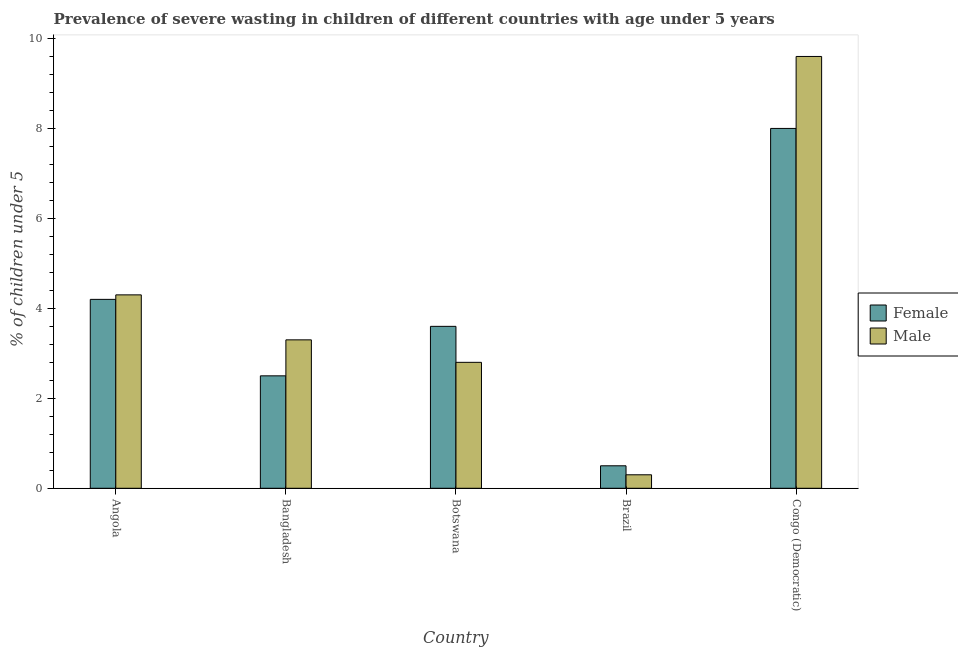How many different coloured bars are there?
Provide a short and direct response. 2. How many groups of bars are there?
Your answer should be compact. 5. Are the number of bars per tick equal to the number of legend labels?
Provide a short and direct response. Yes. How many bars are there on the 1st tick from the right?
Offer a terse response. 2. What is the label of the 4th group of bars from the left?
Offer a very short reply. Brazil. Across all countries, what is the maximum percentage of undernourished male children?
Your response must be concise. 9.6. Across all countries, what is the minimum percentage of undernourished male children?
Your answer should be very brief. 0.3. In which country was the percentage of undernourished male children maximum?
Ensure brevity in your answer.  Congo (Democratic). In which country was the percentage of undernourished female children minimum?
Your answer should be very brief. Brazil. What is the total percentage of undernourished male children in the graph?
Offer a very short reply. 20.3. What is the difference between the percentage of undernourished female children in Botswana and that in Congo (Democratic)?
Your answer should be very brief. -4.4. What is the difference between the percentage of undernourished female children in Brazil and the percentage of undernourished male children in Botswana?
Offer a very short reply. -2.3. What is the average percentage of undernourished male children per country?
Offer a terse response. 4.06. What is the difference between the percentage of undernourished male children and percentage of undernourished female children in Bangladesh?
Your answer should be compact. 0.8. In how many countries, is the percentage of undernourished male children greater than 6.4 %?
Give a very brief answer. 1. What is the ratio of the percentage of undernourished male children in Bangladesh to that in Congo (Democratic)?
Your answer should be very brief. 0.34. Is the percentage of undernourished male children in Bangladesh less than that in Botswana?
Your response must be concise. No. Is the difference between the percentage of undernourished male children in Brazil and Congo (Democratic) greater than the difference between the percentage of undernourished female children in Brazil and Congo (Democratic)?
Offer a terse response. No. What is the difference between the highest and the second highest percentage of undernourished male children?
Make the answer very short. 5.3. What is the difference between the highest and the lowest percentage of undernourished male children?
Your answer should be compact. 9.3. In how many countries, is the percentage of undernourished female children greater than the average percentage of undernourished female children taken over all countries?
Make the answer very short. 2. Is the sum of the percentage of undernourished male children in Angola and Congo (Democratic) greater than the maximum percentage of undernourished female children across all countries?
Give a very brief answer. Yes. What does the 2nd bar from the left in Brazil represents?
Your answer should be very brief. Male. What does the 1st bar from the right in Botswana represents?
Your response must be concise. Male. How many countries are there in the graph?
Provide a short and direct response. 5. What is the difference between two consecutive major ticks on the Y-axis?
Keep it short and to the point. 2. Are the values on the major ticks of Y-axis written in scientific E-notation?
Your answer should be compact. No. How many legend labels are there?
Give a very brief answer. 2. How are the legend labels stacked?
Make the answer very short. Vertical. What is the title of the graph?
Offer a terse response. Prevalence of severe wasting in children of different countries with age under 5 years. Does "Travel services" appear as one of the legend labels in the graph?
Your answer should be very brief. No. What is the label or title of the X-axis?
Offer a very short reply. Country. What is the label or title of the Y-axis?
Ensure brevity in your answer.   % of children under 5. What is the  % of children under 5 of Female in Angola?
Provide a short and direct response. 4.2. What is the  % of children under 5 in Male in Angola?
Keep it short and to the point. 4.3. What is the  % of children under 5 in Female in Bangladesh?
Offer a very short reply. 2.5. What is the  % of children under 5 in Male in Bangladesh?
Your answer should be very brief. 3.3. What is the  % of children under 5 of Female in Botswana?
Your response must be concise. 3.6. What is the  % of children under 5 in Male in Botswana?
Your response must be concise. 2.8. What is the  % of children under 5 of Female in Brazil?
Your answer should be compact. 0.5. What is the  % of children under 5 in Male in Brazil?
Offer a terse response. 0.3. What is the  % of children under 5 of Female in Congo (Democratic)?
Your response must be concise. 8. What is the  % of children under 5 of Male in Congo (Democratic)?
Your response must be concise. 9.6. Across all countries, what is the maximum  % of children under 5 in Female?
Provide a short and direct response. 8. Across all countries, what is the maximum  % of children under 5 of Male?
Make the answer very short. 9.6. Across all countries, what is the minimum  % of children under 5 of Male?
Your answer should be compact. 0.3. What is the total  % of children under 5 in Male in the graph?
Keep it short and to the point. 20.3. What is the difference between the  % of children under 5 in Male in Angola and that in Bangladesh?
Your answer should be very brief. 1. What is the difference between the  % of children under 5 of Male in Angola and that in Brazil?
Provide a succinct answer. 4. What is the difference between the  % of children under 5 in Female in Angola and that in Congo (Democratic)?
Ensure brevity in your answer.  -3.8. What is the difference between the  % of children under 5 of Male in Angola and that in Congo (Democratic)?
Your answer should be very brief. -5.3. What is the difference between the  % of children under 5 in Female in Bangladesh and that in Brazil?
Give a very brief answer. 2. What is the difference between the  % of children under 5 of Male in Bangladesh and that in Brazil?
Offer a terse response. 3. What is the difference between the  % of children under 5 of Female in Bangladesh and that in Congo (Democratic)?
Provide a succinct answer. -5.5. What is the difference between the  % of children under 5 in Male in Bangladesh and that in Congo (Democratic)?
Provide a succinct answer. -6.3. What is the difference between the  % of children under 5 in Female in Botswana and that in Brazil?
Provide a short and direct response. 3.1. What is the difference between the  % of children under 5 of Male in Botswana and that in Brazil?
Provide a short and direct response. 2.5. What is the difference between the  % of children under 5 in Female in Botswana and that in Congo (Democratic)?
Your response must be concise. -4.4. What is the difference between the  % of children under 5 of Male in Botswana and that in Congo (Democratic)?
Keep it short and to the point. -6.8. What is the difference between the  % of children under 5 in Female in Brazil and that in Congo (Democratic)?
Your response must be concise. -7.5. What is the difference between the  % of children under 5 in Male in Brazil and that in Congo (Democratic)?
Your response must be concise. -9.3. What is the difference between the  % of children under 5 of Female in Angola and the  % of children under 5 of Male in Botswana?
Give a very brief answer. 1.4. What is the difference between the  % of children under 5 of Female in Angola and the  % of children under 5 of Male in Brazil?
Provide a short and direct response. 3.9. What is the difference between the  % of children under 5 of Female in Angola and the  % of children under 5 of Male in Congo (Democratic)?
Your answer should be very brief. -5.4. What is the difference between the  % of children under 5 of Female in Bangladesh and the  % of children under 5 of Male in Brazil?
Offer a very short reply. 2.2. What is the difference between the  % of children under 5 in Female in Bangladesh and the  % of children under 5 in Male in Congo (Democratic)?
Provide a succinct answer. -7.1. What is the difference between the  % of children under 5 of Female in Botswana and the  % of children under 5 of Male in Congo (Democratic)?
Ensure brevity in your answer.  -6. What is the difference between the  % of children under 5 in Female in Brazil and the  % of children under 5 in Male in Congo (Democratic)?
Your response must be concise. -9.1. What is the average  % of children under 5 in Female per country?
Provide a short and direct response. 3.76. What is the average  % of children under 5 in Male per country?
Your response must be concise. 4.06. What is the difference between the  % of children under 5 of Female and  % of children under 5 of Male in Angola?
Your answer should be very brief. -0.1. What is the difference between the  % of children under 5 of Female and  % of children under 5 of Male in Bangladesh?
Provide a short and direct response. -0.8. What is the ratio of the  % of children under 5 of Female in Angola to that in Bangladesh?
Your response must be concise. 1.68. What is the ratio of the  % of children under 5 in Male in Angola to that in Bangladesh?
Make the answer very short. 1.3. What is the ratio of the  % of children under 5 in Male in Angola to that in Botswana?
Your answer should be compact. 1.54. What is the ratio of the  % of children under 5 of Male in Angola to that in Brazil?
Give a very brief answer. 14.33. What is the ratio of the  % of children under 5 in Female in Angola to that in Congo (Democratic)?
Make the answer very short. 0.53. What is the ratio of the  % of children under 5 of Male in Angola to that in Congo (Democratic)?
Provide a short and direct response. 0.45. What is the ratio of the  % of children under 5 of Female in Bangladesh to that in Botswana?
Give a very brief answer. 0.69. What is the ratio of the  % of children under 5 of Male in Bangladesh to that in Botswana?
Ensure brevity in your answer.  1.18. What is the ratio of the  % of children under 5 of Female in Bangladesh to that in Brazil?
Ensure brevity in your answer.  5. What is the ratio of the  % of children under 5 of Female in Bangladesh to that in Congo (Democratic)?
Give a very brief answer. 0.31. What is the ratio of the  % of children under 5 in Male in Bangladesh to that in Congo (Democratic)?
Provide a succinct answer. 0.34. What is the ratio of the  % of children under 5 of Male in Botswana to that in Brazil?
Keep it short and to the point. 9.33. What is the ratio of the  % of children under 5 in Female in Botswana to that in Congo (Democratic)?
Keep it short and to the point. 0.45. What is the ratio of the  % of children under 5 of Male in Botswana to that in Congo (Democratic)?
Give a very brief answer. 0.29. What is the ratio of the  % of children under 5 in Female in Brazil to that in Congo (Democratic)?
Your response must be concise. 0.06. What is the ratio of the  % of children under 5 in Male in Brazil to that in Congo (Democratic)?
Offer a very short reply. 0.03. What is the difference between the highest and the lowest  % of children under 5 in Male?
Provide a succinct answer. 9.3. 